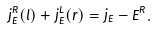<formula> <loc_0><loc_0><loc_500><loc_500>j _ { E } ^ { R } ( l ) + j _ { E } ^ { L } ( r ) = j _ { E } - \dot { E } ^ { R } .</formula> 